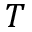<formula> <loc_0><loc_0><loc_500><loc_500>T</formula> 